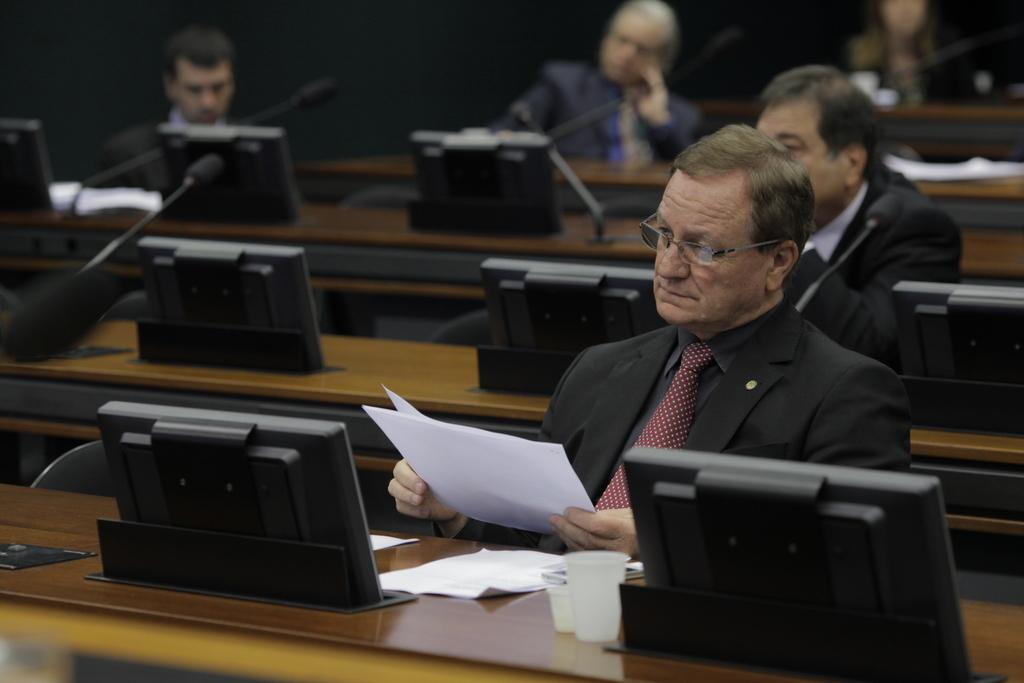What are the men in the image doing? The men in the image are sitting on chairs. What objects are placed in front of the men? Tables are placed in front of the men. What can be found on the tables? There are desktops, glass tumblers, and papers on the tables. What type of wine is being served in the glass tumblers in the image? There is no wine present in the image; only glass tumblers are mentioned. What is the purpose of the pump in the image? There is no pump present in the image. 